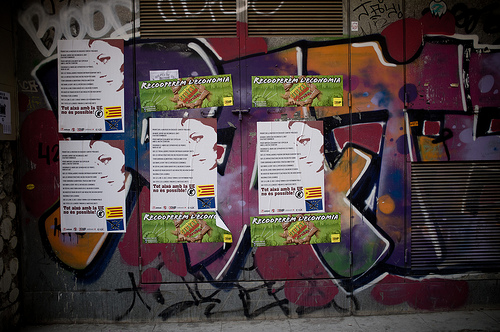<image>
Is the woman in the graffiti? Yes. The woman is contained within or inside the graffiti, showing a containment relationship. Where is the poster in relation to the grafitti? Is it in front of the grafitti? Yes. The poster is positioned in front of the grafitti, appearing closer to the camera viewpoint. 